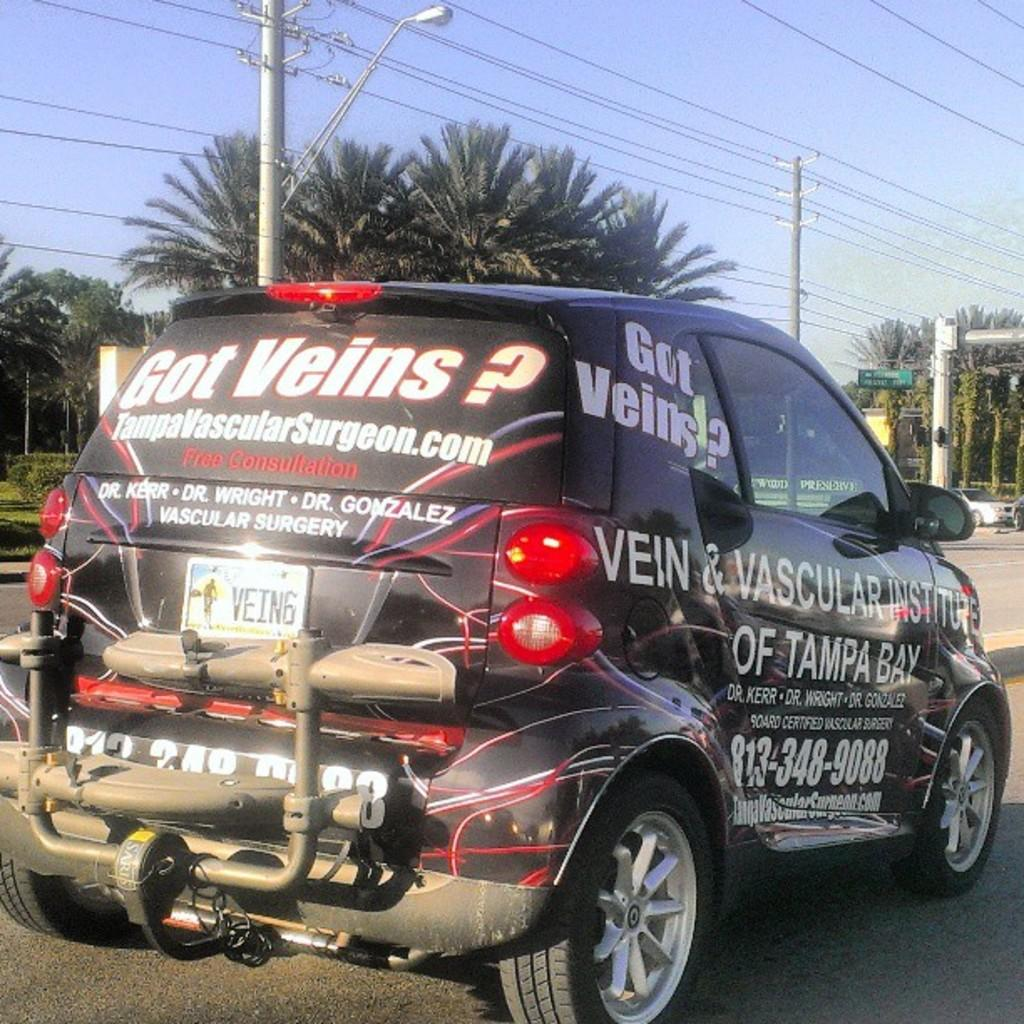What is the color of the car in the image? The car in the image is black. What is written on the car? The car has quotes written on it. What is the car doing in the image? The car is moving on the road. What can be seen in the background of the image? There are coconut trees and an electric pole with many cables in the background of the image. Can you see any sidewalks in the image? There is no sidewalk visible in the image; it only shows a car moving on the road and the background. 